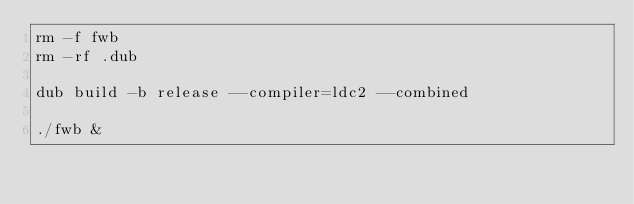<code> <loc_0><loc_0><loc_500><loc_500><_Bash_>rm -f fwb
rm -rf .dub

dub build -b release --compiler=ldc2 --combined

./fwb &
</code> 